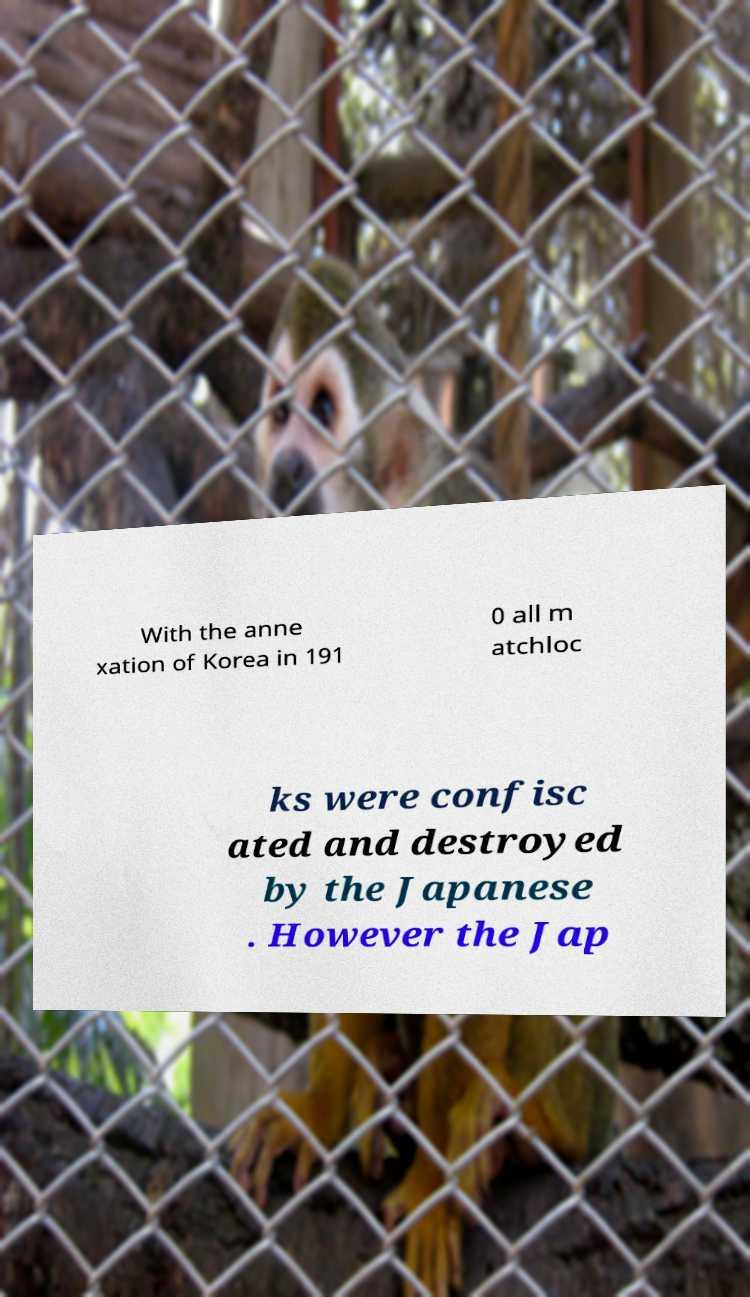Please read and relay the text visible in this image. What does it say? With the anne xation of Korea in 191 0 all m atchloc ks were confisc ated and destroyed by the Japanese . However the Jap 